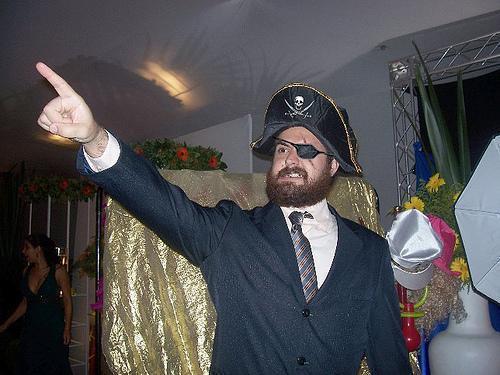If you had to guess which holiday would this most likely be?
Choose the right answer and clarify with the format: 'Answer: answer
Rationale: rationale.'
Options: Thanksgiving, christmas, new years, halloween. Answer: halloween.
Rationale: The man is wearing a pirate costume. this would not be a suitable outfit for christmas, thanksgiving, or new years. 